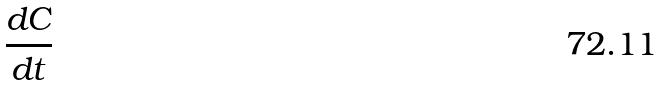Convert formula to latex. <formula><loc_0><loc_0><loc_500><loc_500>\frac { d C } { d t }</formula> 